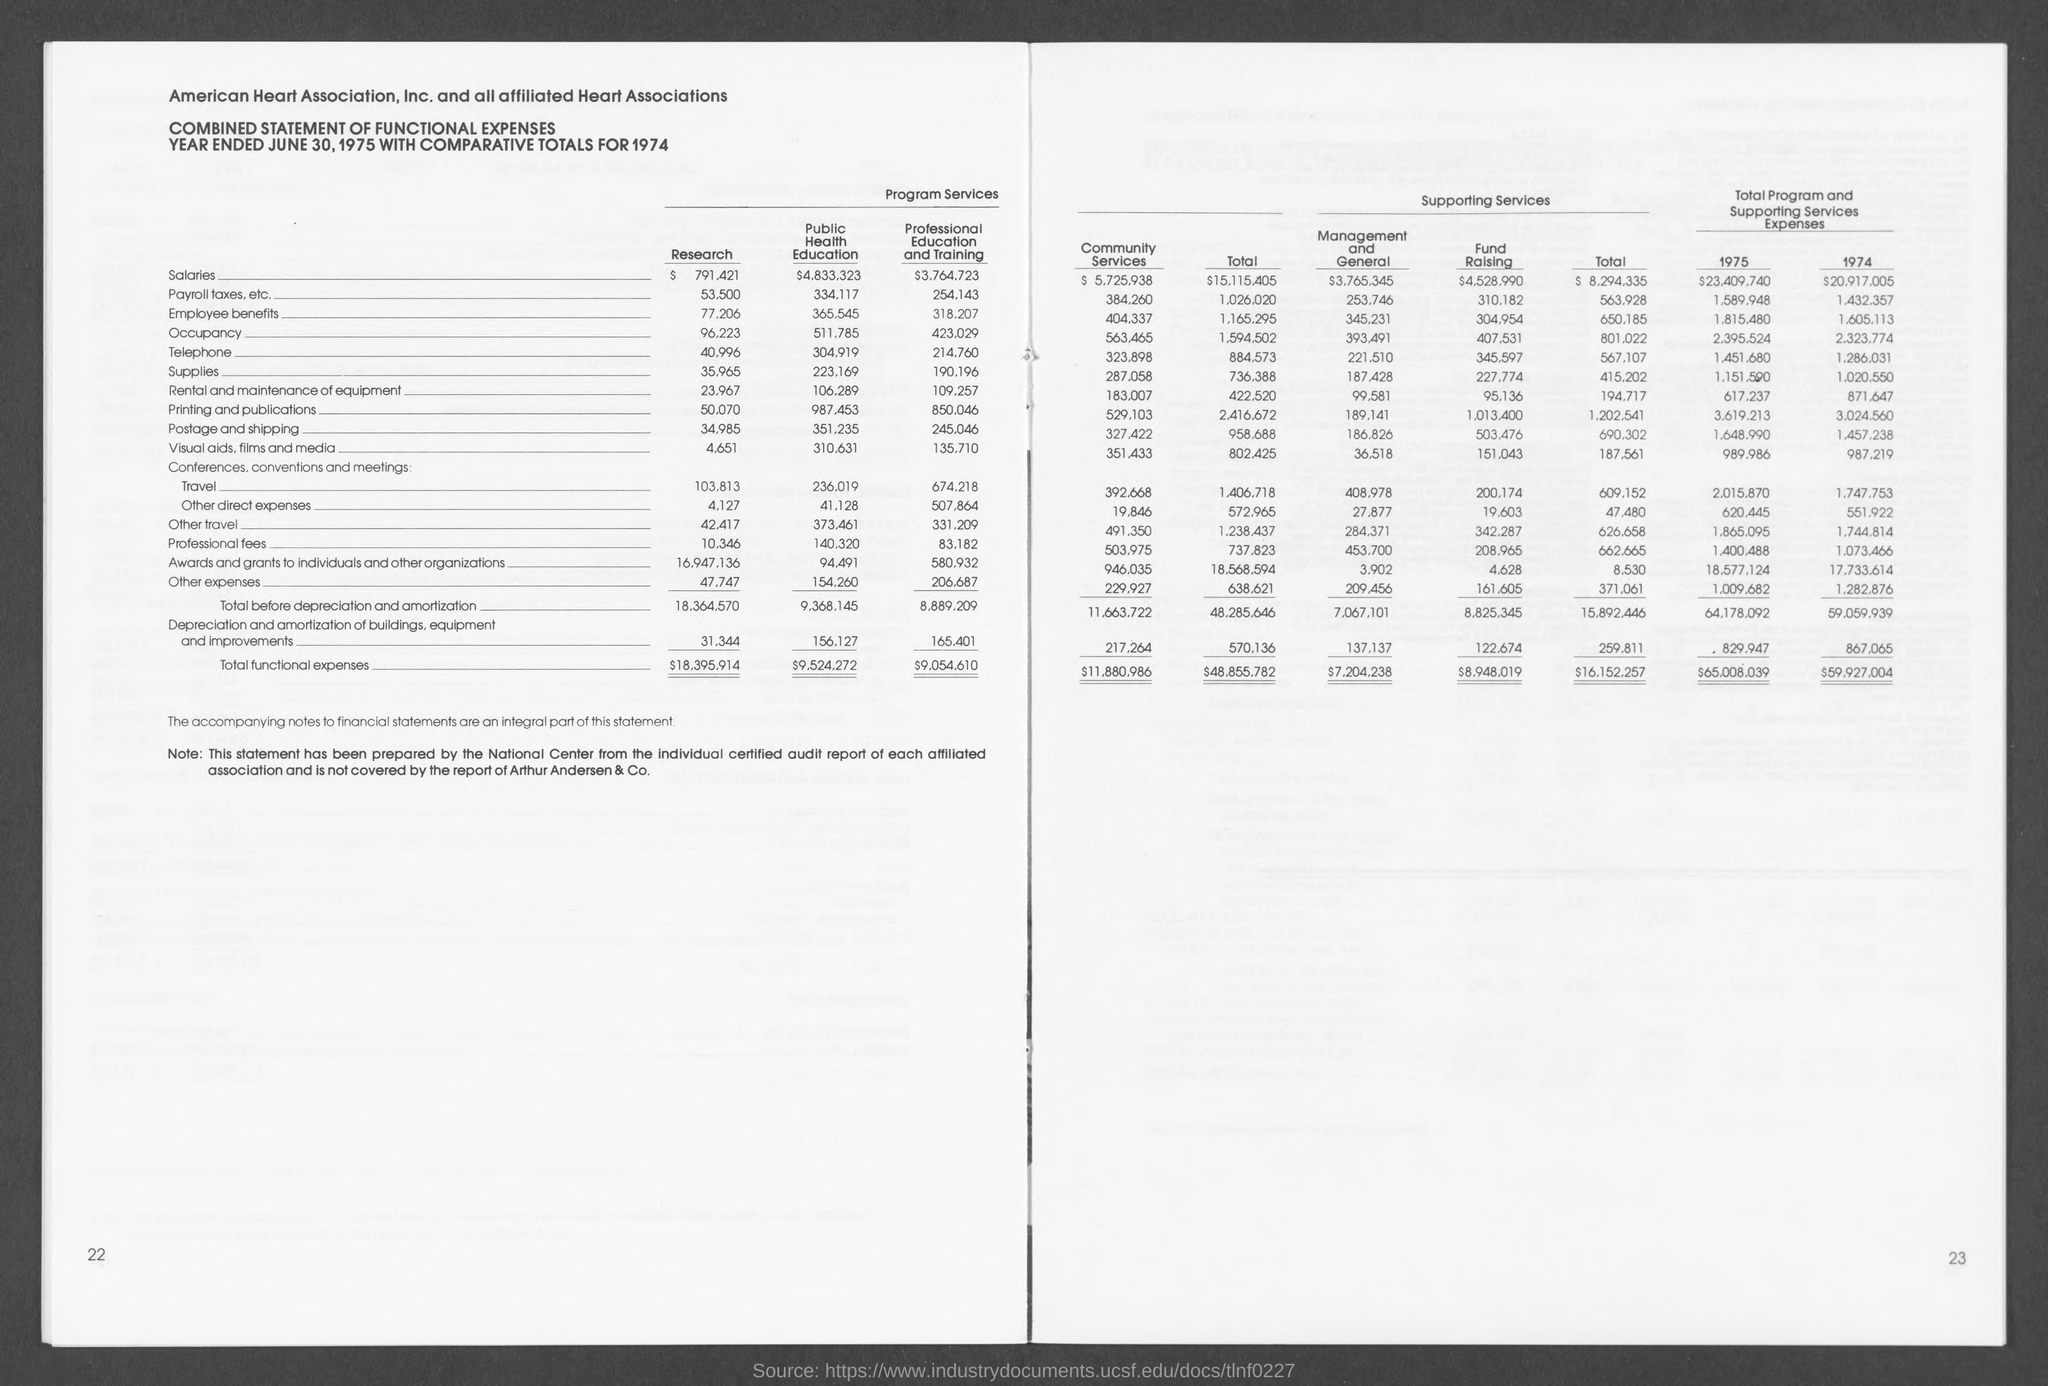What is the Total functional costs for Research?
Provide a succinct answer. 18,395.914. What is the Total functional costs for Public Health Education?
Ensure brevity in your answer.  $9,524,272. What is the Total functional costs for Professional education and training?
Provide a short and direct response. 9,054,610. 